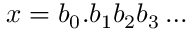<formula> <loc_0><loc_0><loc_500><loc_500>x = b _ { 0 } . b _ { 1 } b _ { 2 } b _ { 3 } \dots</formula> 